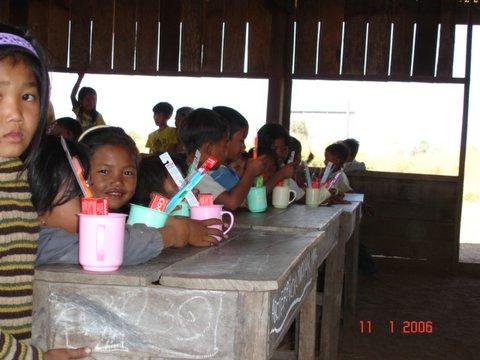Why is there only pink green and white cups in the picture?
Be succinct. Birthday. Which child is the most likely to be blamed for ruining the composition of this photograph?
Short answer required. Middle child. When was this picture taken?
Keep it brief. 11/1/2006. What do the girls have in their cups?
Keep it brief. Toothbrush and toothpaste. 